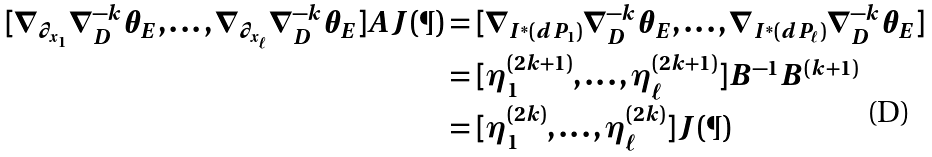Convert formula to latex. <formula><loc_0><loc_0><loc_500><loc_500>[ \nabla _ { \partial _ { x _ { 1 } } } \nabla _ { D } ^ { - k } \theta _ { E } , \dots , \nabla _ { \partial _ { x _ { \ell } } } \nabla _ { D } ^ { - k } \theta _ { E } ] A J ( \P ) & = [ \nabla _ { I ^ { * } ( d P _ { 1 } ) } \nabla _ { D } ^ { - k } \theta _ { E } , \dots , \nabla _ { I ^ { * } ( d P _ { \ell } ) } \nabla _ { D } ^ { - k } \theta _ { E } ] \\ & = [ \eta _ { 1 } ^ { ( 2 k + 1 ) } , \dots , \eta _ { \ell } ^ { ( 2 k + 1 ) } ] B ^ { - 1 } B ^ { ( k + 1 ) } \\ & = [ \eta _ { 1 } ^ { ( 2 k ) } , \dots , \eta _ { \ell } ^ { ( 2 k ) } ] J ( \P )</formula> 